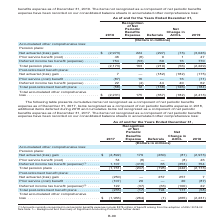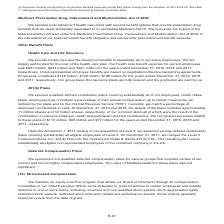According to Centurylink's financial document, What does the deferred income tax benefit (expense) under pension plans currently recognize?  Amounts currently recognized in net periodic benefits expense include $375 million of benefit arising from the adoption of ASU 2018-02. The document states: "(1) Amounts currently recognized in net periodic benefits expense include $375 million of benefit arising from the adoption of ASU 2018-02. See Note 1..." Also, What does the deferred income tax benefit (expense) under post-retirement benefit plans currently recognize?  Amounts currently recognized in net periodic benefits expense include $32 million arising from the adoption of ASU 2018-02. The document states: "(2) Amounts currently recognized in net periodic benefits expense include $32 million arising from the adoption of ASU 2018-02. See Note 1— Background..." Also, What does the table show? presents cumulative items not recognized as a component of net periodic benefits expense as of December 31, 2017, items recognized as a component of net periodic benefits expense in 2018, additional items deferred during 2018 and cumulative items not recognized as a component of net periodic benefits expense as of December 31, 2017. The document states: "The following table presents cumulative items not recognized as a component of net periodic benefits expense as of December 31, 2017, items recognized..." Additionally, In which year is the prior service benefit (cost) for pension plans larger? According to the financial document, 2017. The relevant text states: "net periodic benefits expense as of December 31, 2017, items recognized as a component of net periodic benefits expense in 2018, additional items deferre..." Also, can you calculate: What is the sum of the prior service benefit (cost) for pension plans in 2017 and 2018? Based on the calculation: 54+46, the result is 100 (in millions). This is based on the information: "(260) (81) (2,973) Prior service benefit (cost) . 54 (8) — (8) 46 Deferred income tax benefit (expense) (1) . 1,107 (418) 65 (353) 754 ,973) Prior service benefit (cost) . 54 (8) — (8) 46 Deferred inc..." The key data points involved are: 46, 54. Also, can you calculate: What is the percentage change in the deferred income tax benefit (expense) for post-retirement benefit plans in 2018 from 2017? To answer this question, I need to perform calculations using the financial data. The calculation is: (22-122)/122, which equals -81.97 (percentage). This is based on the information: "(87) Deferred income tax benefit (expense) (2) . 122 (37) (63) (100) 22 (87) Deferred income tax benefit (expense) (2) . 122 (37) (63) (100) 22..." The key data points involved are: 122, 22. 